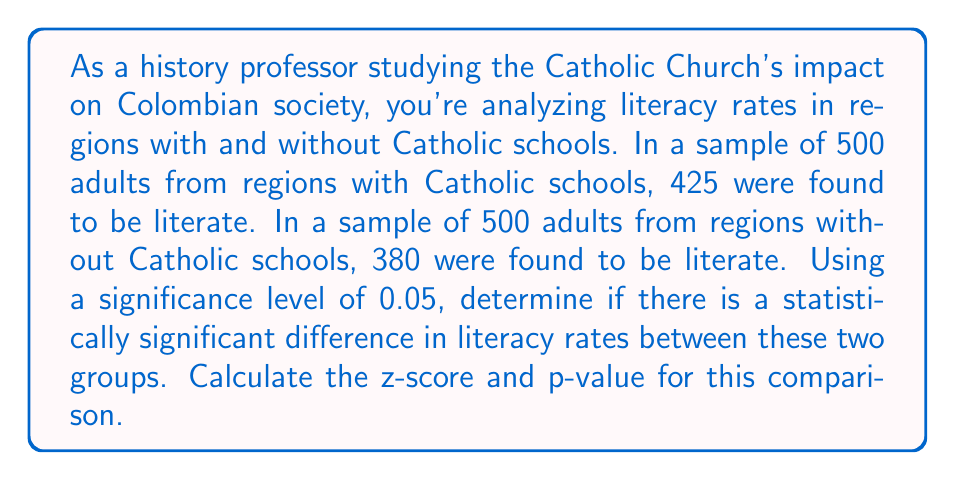Provide a solution to this math problem. To determine if there's a statistically significant difference in literacy rates, we'll use a two-proportion z-test. Let's follow these steps:

1. Define our hypotheses:
   $H_0: p_1 = p_2$ (null hypothesis: no difference in proportions)
   $H_a: p_1 \neq p_2$ (alternative hypothesis: there is a difference)

   Where $p_1$ is the proportion of literate adults in regions with Catholic schools and $p_2$ is the proportion in regions without.

2. Calculate the sample proportions:
   $\hat{p}_1 = 425/500 = 0.85$
   $\hat{p}_2 = 380/500 = 0.76$

3. Calculate the pooled proportion:
   $$\hat{p} = \frac{425 + 380}{500 + 500} = \frac{805}{1000} = 0.805$$

4. Calculate the standard error:
   $$SE = \sqrt{\hat{p}(1-\hat{p})(\frac{1}{n_1} + \frac{1}{n_2})}$$
   $$SE = \sqrt{0.805(1-0.805)(\frac{1}{500} + \frac{1}{500})} = 0.0250$$

5. Calculate the z-score:
   $$z = \frac{\hat{p}_1 - \hat{p}_2}{SE} = \frac{0.85 - 0.76}{0.0250} = 3.60$$

6. Find the p-value:
   For a two-tailed test, p-value = $2 * P(Z > |3.60|)$
   Using a standard normal distribution table or calculator, we find:
   p-value $\approx 2 * 0.00016 = 0.00032$

7. Compare the p-value to the significance level:
   0.00032 < 0.05

Since the p-value is less than the significance level, we reject the null hypothesis. This suggests that there is a statistically significant difference in literacy rates between regions with and without Catholic schools in Colombia.
Answer: z-score = 3.60, p-value ≈ 0.00032. There is a statistically significant difference in literacy rates between the two groups at the 0.05 significance level. 